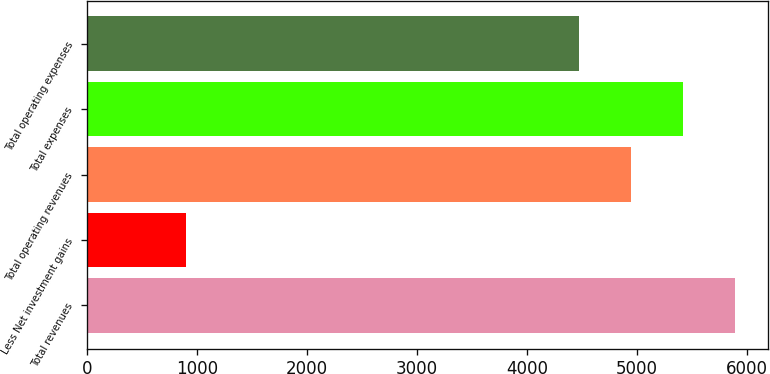Convert chart. <chart><loc_0><loc_0><loc_500><loc_500><bar_chart><fcel>Total revenues<fcel>Less Net investment gains<fcel>Total operating revenues<fcel>Total expenses<fcel>Total operating expenses<nl><fcel>5890.7<fcel>901<fcel>4944.9<fcel>5417.8<fcel>4472<nl></chart> 